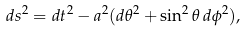<formula> <loc_0><loc_0><loc_500><loc_500>d s ^ { 2 } = d t ^ { 2 } - a ^ { 2 } ( d \theta ^ { 2 } + \sin ^ { 2 } \theta \, d \phi ^ { 2 } ) ,</formula> 